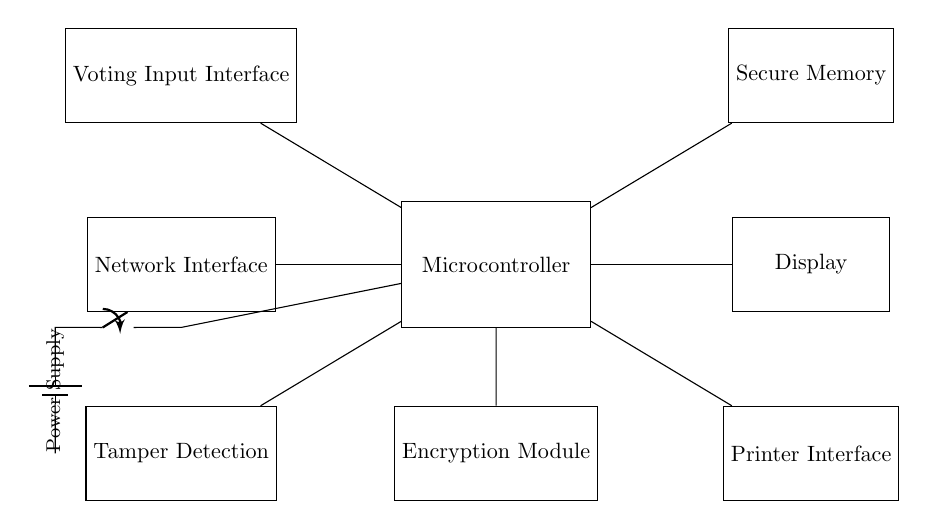What components connect to the microcontroller? The microcontroller is connected to the Voting Input Interface, Secure Memory, Display, Encryption Module, Tamper Detection, Printer Interface, and Network Interface, which are all represented as rectangles in the circuit diagram.
Answer: Voting Input Interface, Secure Memory, Display, Encryption Module, Tamper Detection, Printer Interface, Network Interface What does the encryption module do? The encryption module is used to secure the data processed by the microcontroller, ensuring that sensitive information, such as votes, is protected during transmission and storage. This is crucial for the integrity of electronic voting systems.
Answer: Secure the data Which component detects tampering? The Tamper Detection component is responsible for monitoring the circuit for any unauthorized access or modifications, triggering alerts if tampering is detected. This helps maintain the security of the voting machine.
Answer: Tamper Detection How does the power supply connect to the circuit? The power supply connects to the microcontroller through a battery and a switch, creating a direct supply route to power the entire circuit. The switch allows for the control of power to the microcontroller, ensuring it operates only when needed.
Answer: Through a battery and a switch What is the function of the printer interface? The printer interface allows the microcontroller to send data to a printer, which can be used to produce physical copies of the votes processed or other relevant information, enhancing transparency and verification of the election process.
Answer: Produce physical copies What are the potential outputs of this circuit? The outputs of this circuit can include displayed results, printed documents, and data sent over a network (if applicable), which are derived from the processing of user votes and other inputs via the microcontroller.
Answer: Display, print, network data 